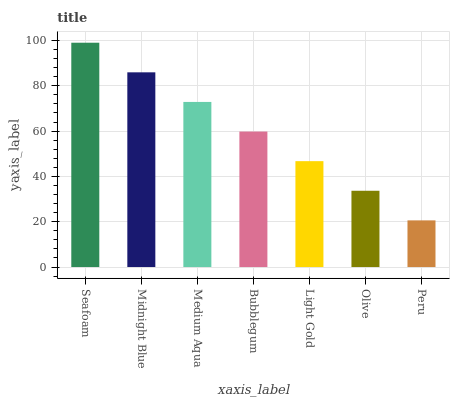Is Peru the minimum?
Answer yes or no. Yes. Is Seafoam the maximum?
Answer yes or no. Yes. Is Midnight Blue the minimum?
Answer yes or no. No. Is Midnight Blue the maximum?
Answer yes or no. No. Is Seafoam greater than Midnight Blue?
Answer yes or no. Yes. Is Midnight Blue less than Seafoam?
Answer yes or no. Yes. Is Midnight Blue greater than Seafoam?
Answer yes or no. No. Is Seafoam less than Midnight Blue?
Answer yes or no. No. Is Bubblegum the high median?
Answer yes or no. Yes. Is Bubblegum the low median?
Answer yes or no. Yes. Is Seafoam the high median?
Answer yes or no. No. Is Seafoam the low median?
Answer yes or no. No. 